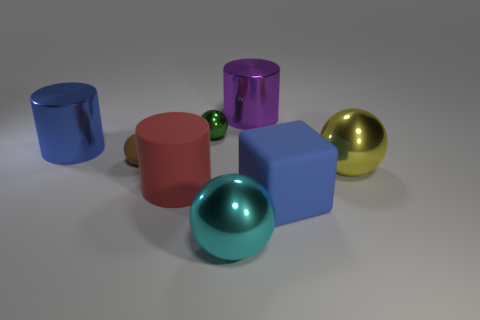What number of other objects are the same color as the big matte cube?
Give a very brief answer. 1. What shape is the yellow metallic thing that is the same size as the cyan metal ball?
Your answer should be very brief. Sphere. How many large things are shiny spheres or green shiny spheres?
Provide a succinct answer. 2. There is a big metallic ball that is on the left side of the metallic thing that is behind the green metallic sphere; are there any tiny green objects in front of it?
Ensure brevity in your answer.  No. Is there a red block that has the same size as the purple cylinder?
Offer a terse response. No. What material is the cube that is the same size as the red cylinder?
Give a very brief answer. Rubber. Do the red cylinder and the shiny sphere behind the tiny brown ball have the same size?
Your answer should be very brief. No. What number of matte things are blue balls or large yellow spheres?
Your answer should be very brief. 0. How many big metal objects have the same shape as the brown rubber thing?
Keep it short and to the point. 2. There is a thing that is the same color as the matte cube; what is it made of?
Provide a succinct answer. Metal. 